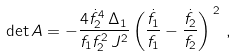Convert formula to latex. <formula><loc_0><loc_0><loc_500><loc_500>\det A = - \frac { 4 \dot { f } _ { 2 } ^ { 4 } \, \Delta _ { 1 } } { f _ { 1 } f _ { 2 } ^ { 2 } \, J ^ { 2 } } \left ( \frac { \dot { f } _ { 1 } } { f _ { 1 } } - \frac { \dot { f } _ { 2 } } { f _ { 2 } } \right ) ^ { \, 2 } \, ,</formula> 